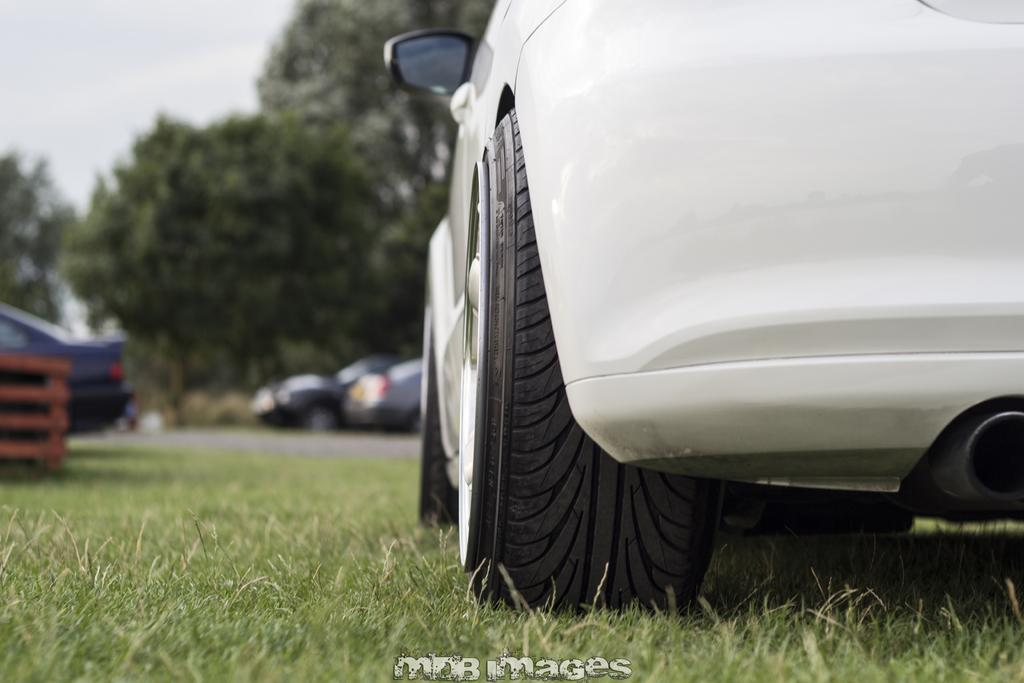What type of vehicles can be seen in the image? There are cars in the image. What type of vegetation is present in the image? There is grass in the image. What can be seen in the background of the image? There are trees and the sky visible in the background of the image. Is there any text or marking at the bottom of the image? Yes, there is a watermark at the bottom of the image. What type of eggs can be seen in the image? There are no eggs present in the image. Is there a hose visible in the image? There is no hose present in the image. 